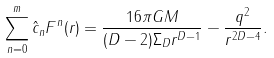Convert formula to latex. <formula><loc_0><loc_0><loc_500><loc_500>\sum ^ { m } _ { n = 0 } \hat { c } _ { n } F ^ { n } ( r ) = \frac { 1 6 \pi G M } { ( D - 2 ) \Sigma _ { D } r ^ { D - 1 } } - \frac { q ^ { 2 } } { r ^ { 2 D - 4 } } .</formula> 